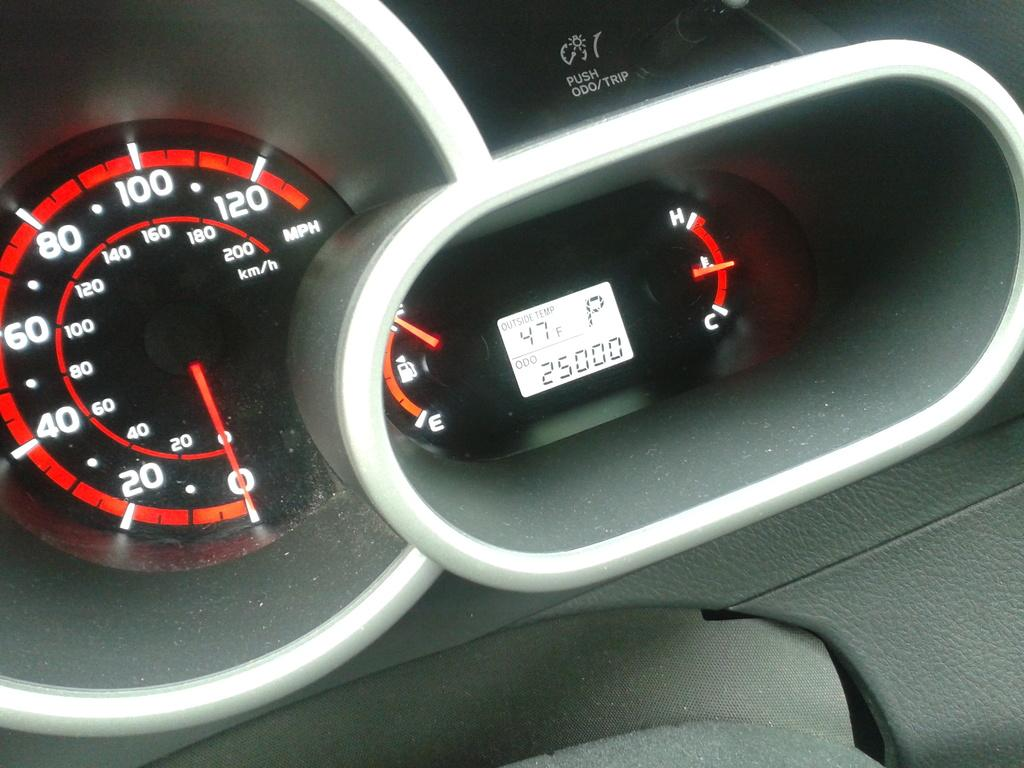What type of location is depicted in the image? The image shows an inside view of a vehicle. What can be seen on the right side of the vehicle? There is a digital meter on the right side of the vehicle. What instrument is located on the left side of the vehicle? There is a speedometer on the left side of the vehicle. What is the income of the driver in the image? There is no information about the driver's income in the image. How does the rub affect the vehicle's performance in the image? There is no mention of rub or any related issues in the image. 